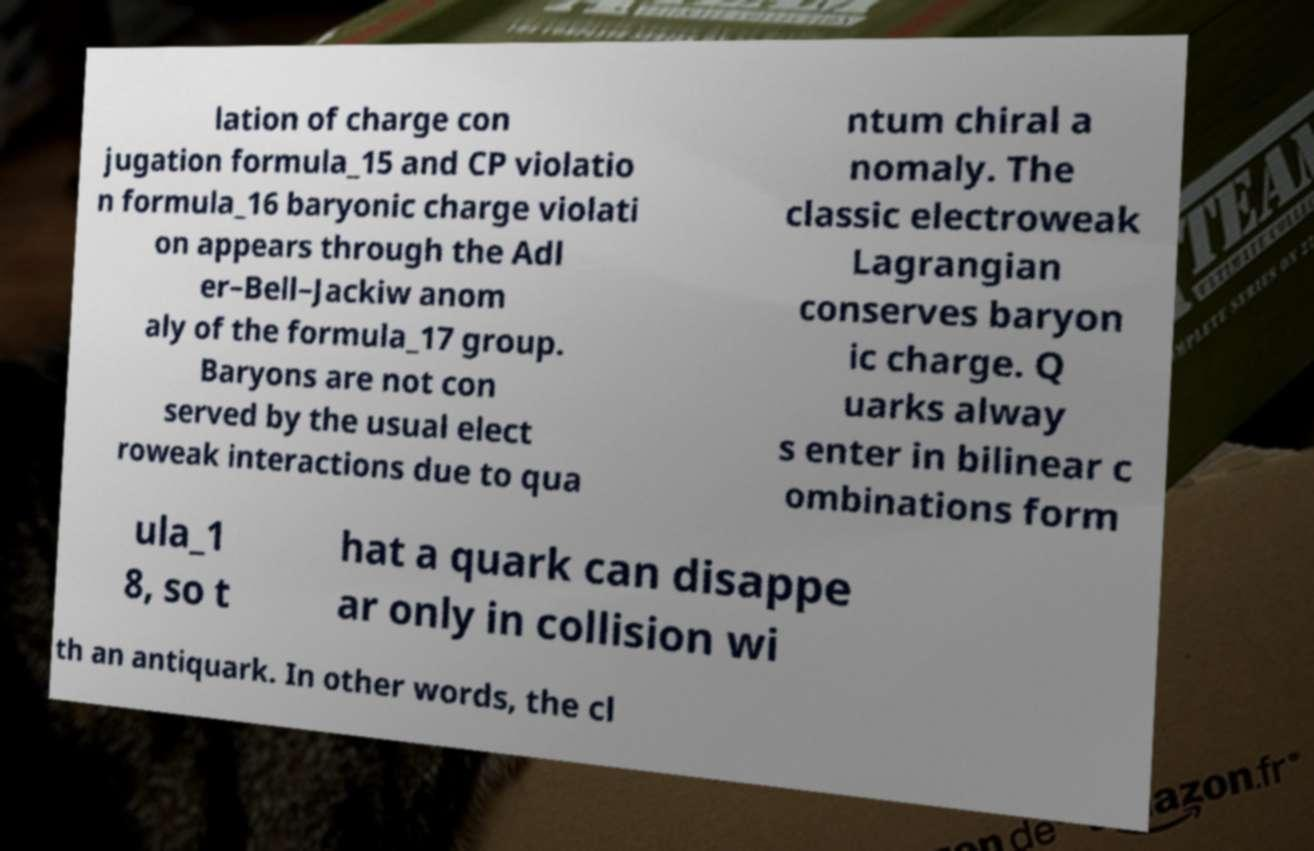Could you assist in decoding the text presented in this image and type it out clearly? lation of charge con jugation formula_15 and CP violatio n formula_16 baryonic charge violati on appears through the Adl er–Bell–Jackiw anom aly of the formula_17 group. Baryons are not con served by the usual elect roweak interactions due to qua ntum chiral a nomaly. The classic electroweak Lagrangian conserves baryon ic charge. Q uarks alway s enter in bilinear c ombinations form ula_1 8, so t hat a quark can disappe ar only in collision wi th an antiquark. In other words, the cl 